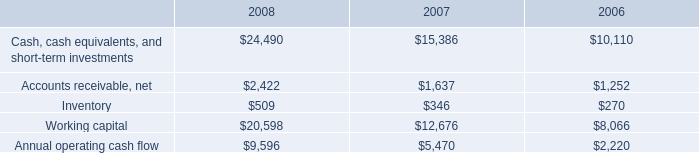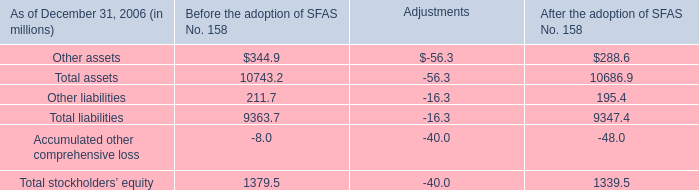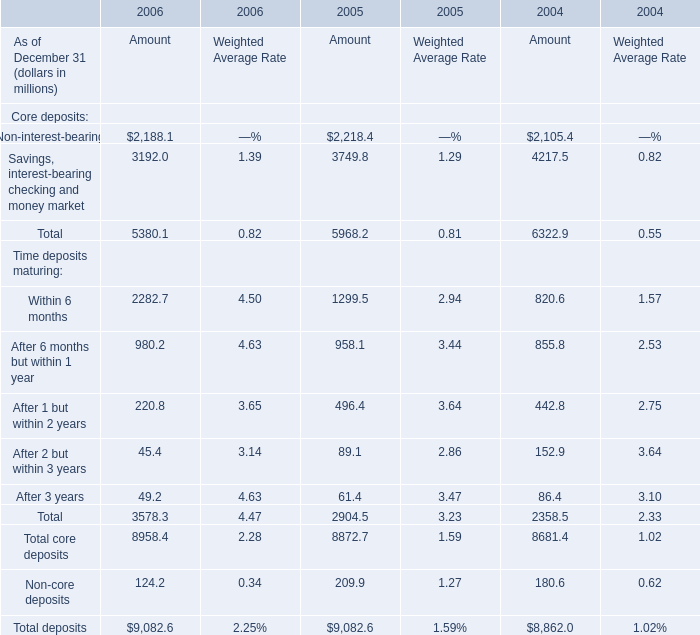If Savings, interest-bearing checking and money market develops with the same increasing rate in 2006, what will it reach in 2007? (in million) 
Computations: ((((3192 - 3749.8) / 3749.8) + 1) * 3192)
Answer: 2717.17532. 